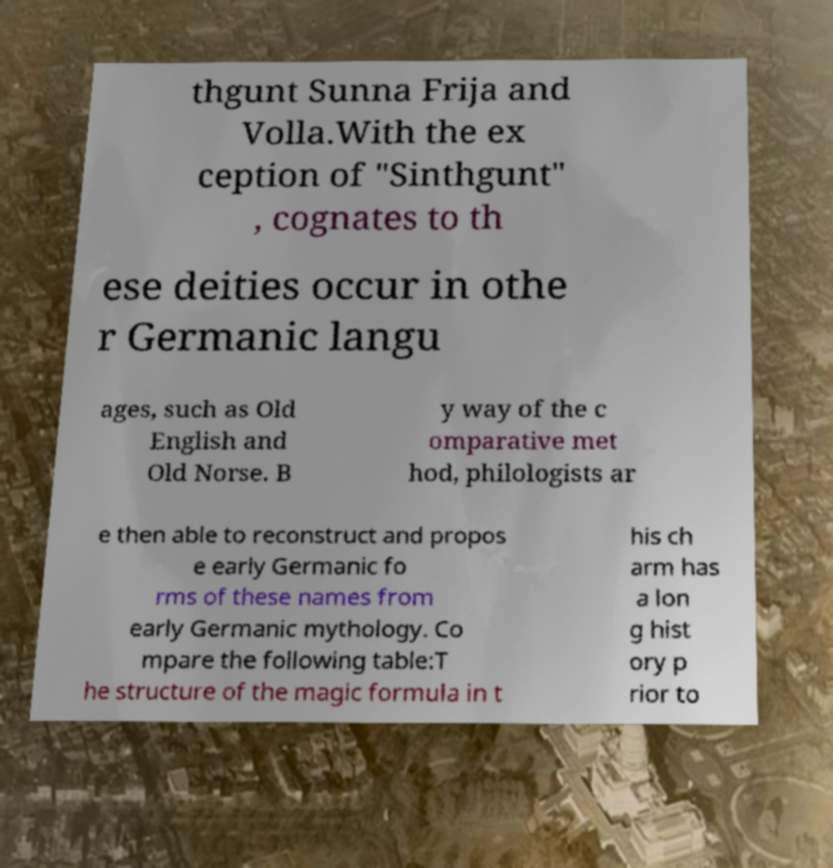There's text embedded in this image that I need extracted. Can you transcribe it verbatim? thgunt Sunna Frija and Volla.With the ex ception of "Sinthgunt" , cognates to th ese deities occur in othe r Germanic langu ages, such as Old English and Old Norse. B y way of the c omparative met hod, philologists ar e then able to reconstruct and propos e early Germanic fo rms of these names from early Germanic mythology. Co mpare the following table:T he structure of the magic formula in t his ch arm has a lon g hist ory p rior to 